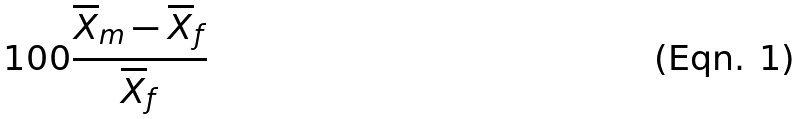Convert formula to latex. <formula><loc_0><loc_0><loc_500><loc_500>1 0 0 \frac { \overline { X } _ { m } - \overline { X } _ { f } } { \overline { X } _ { f } }</formula> 